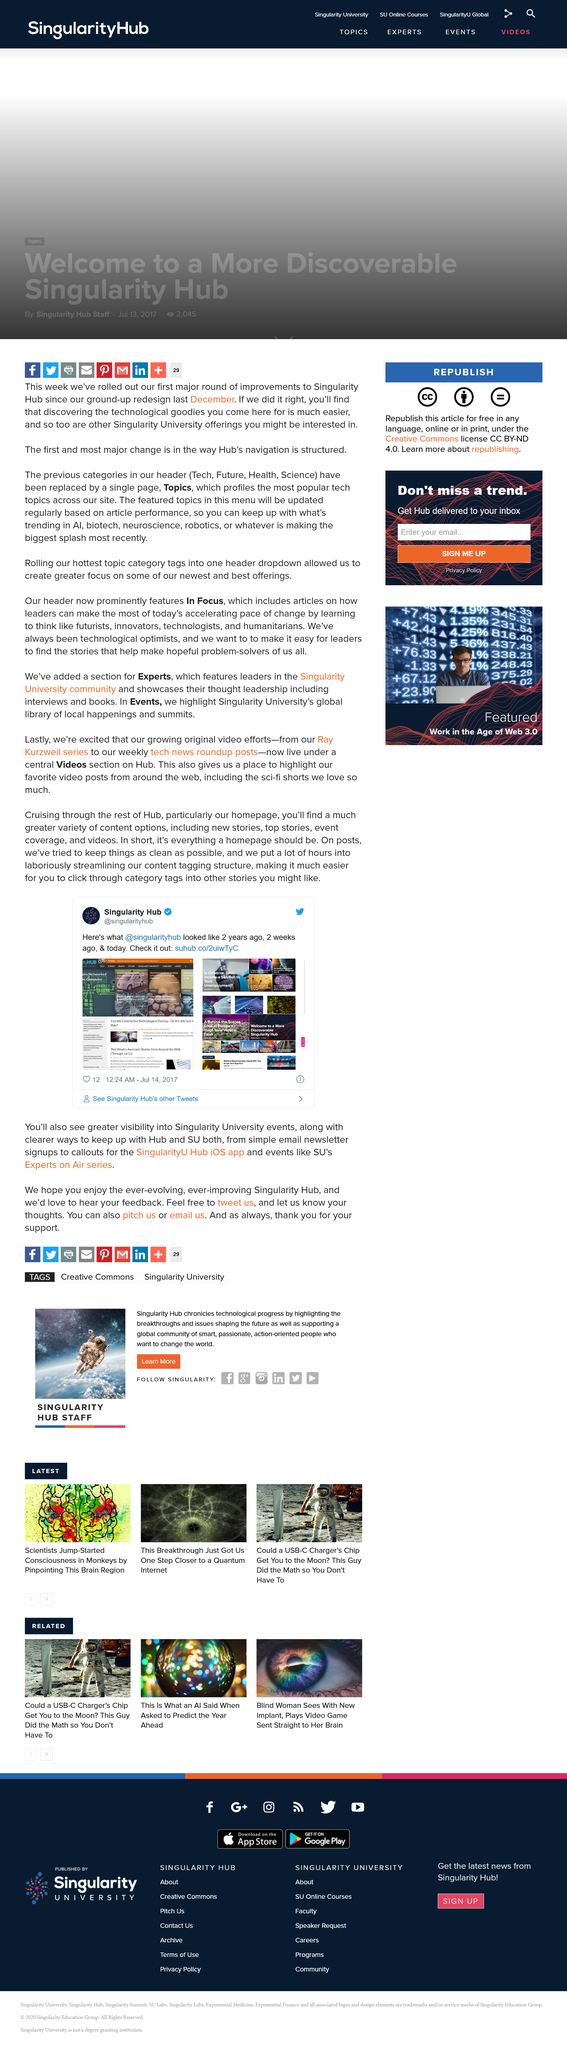Indicate a few pertinent items in this graphic. The year depicted in the screenshot is 2017. The name of the university being discussed in the article is what university? Singularity. The screenshot depicts the appearance of @singularityhub approximately 2 years ago. 